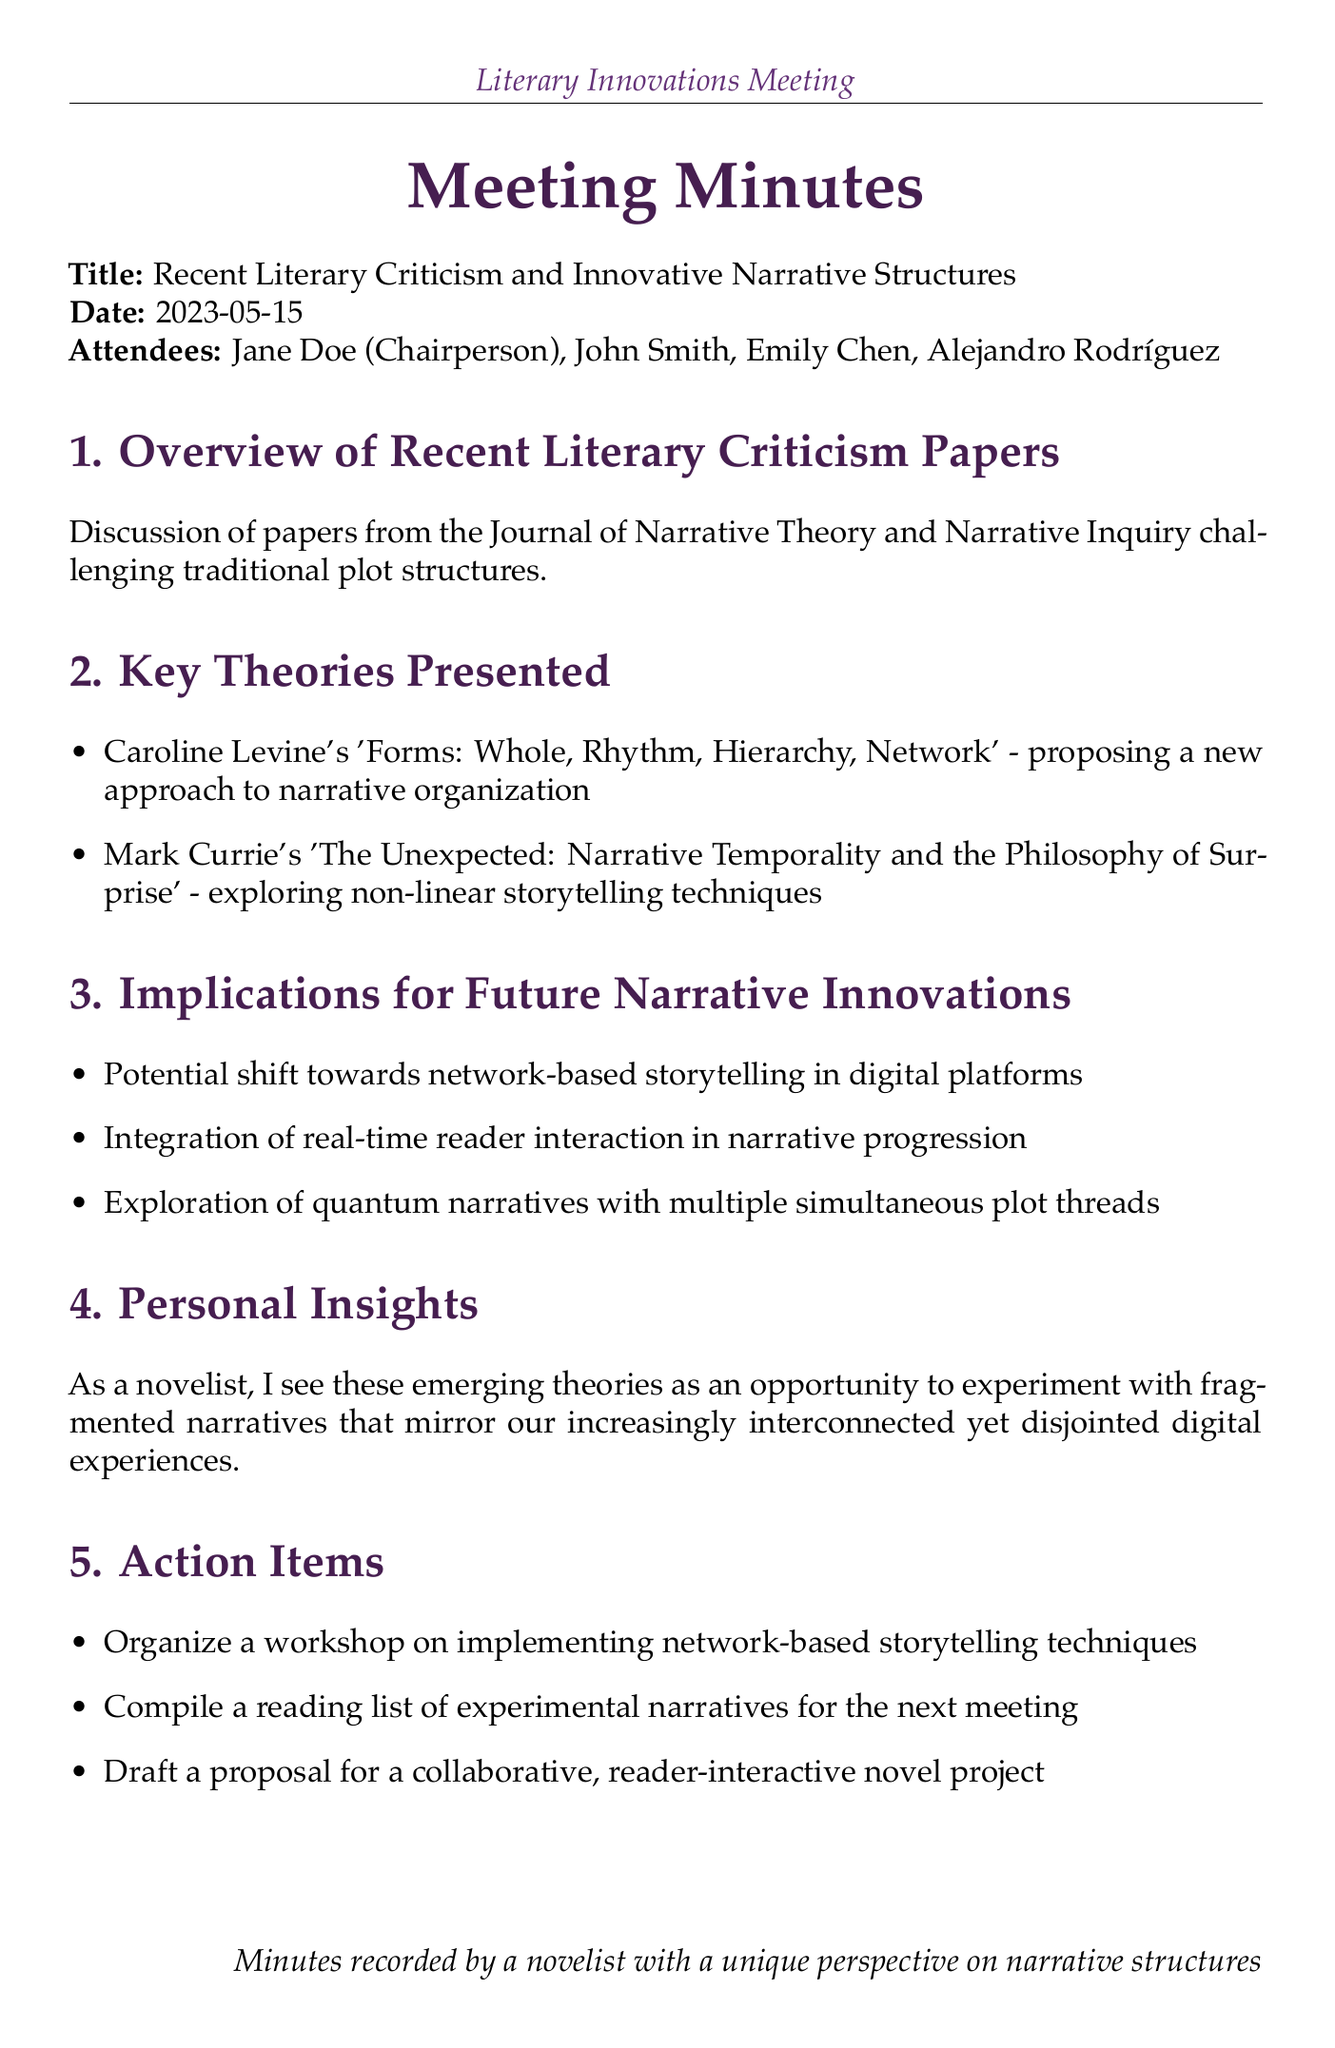what is the meeting title? The meeting title is specifically mentioned at the beginning of the document.
Answer: Recent Literary Criticism and Innovative Narrative Structures who chaired the meeting? The chairperson of the meeting is listed in the attendees section.
Answer: Jane Doe what is the date of the meeting? The date is explicitly stated in the document.
Answer: 2023-05-15 which two key theories were presented? The document lists key theories in the agenda and specifies the authors.
Answer: Caroline Levine's 'Forms: Whole, Rhythm, Hierarchy, Network' and Mark Currie's 'The Unexpected: Narrative Temporality and the Philosophy of Surprise' what is one implication for future narrative innovations? The document mentions various implications in the dedicated section.
Answer: Potential shift towards network-based storytelling in digital platforms what type of narrative approach does Caroline Levine propose? The document states this in the section discussing key theories.
Answer: A new approach to narrative organization how many action items are listed? The number of action items can be counted from the action items section.
Answer: Three what is the purpose of the upcoming workshop? This is detailed in the action items section outlining future activities.
Answer: Implementing network-based storytelling techniques what is a personal insight from the meeting? The document shares personal insights in its dedicated section.
Answer: Opportunity to experiment with fragmented narratives 